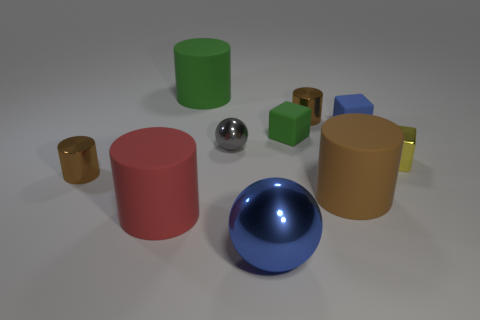Subtract all green matte cylinders. How many cylinders are left? 4 Subtract all green blocks. How many blocks are left? 2 Subtract 3 cylinders. How many cylinders are left? 2 Subtract all gray balls. Subtract all green cylinders. How many balls are left? 1 Subtract all blue spheres. How many gray cylinders are left? 0 Subtract all green matte cylinders. Subtract all gray metallic balls. How many objects are left? 8 Add 5 green rubber things. How many green rubber things are left? 7 Add 6 cyan metal spheres. How many cyan metal spheres exist? 6 Subtract 0 brown balls. How many objects are left? 10 Subtract all spheres. How many objects are left? 8 